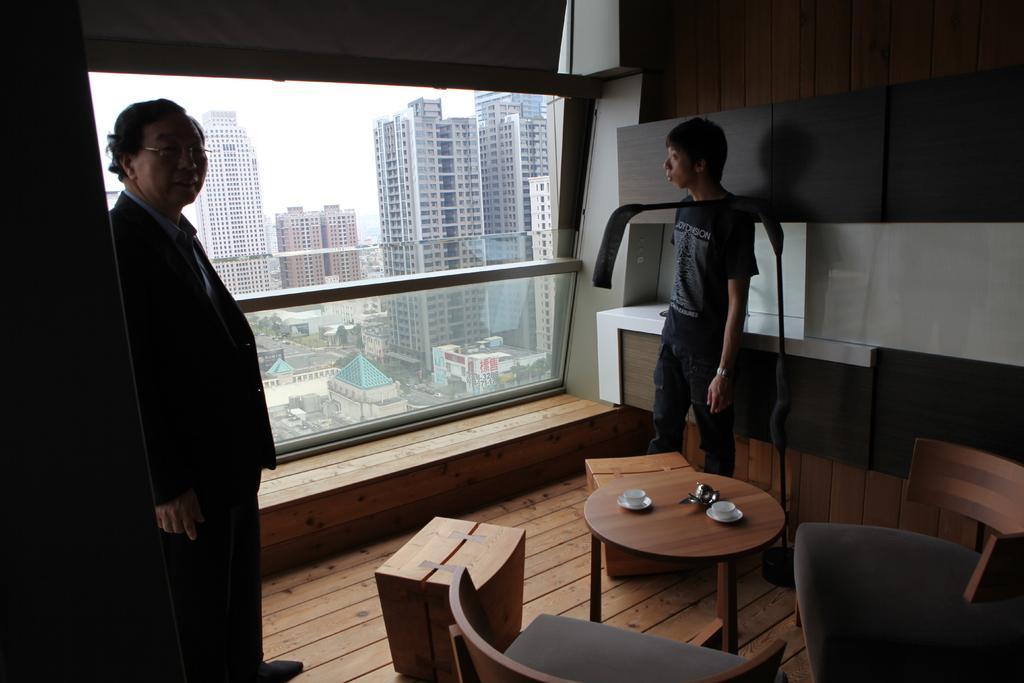In one or two sentences, can you explain what this image depicts? In this image I see 2 men who are standing and I see a table on which there are 2 cups, I can also see 2 chairs and 2 boxes and In the background I see the buildings. 